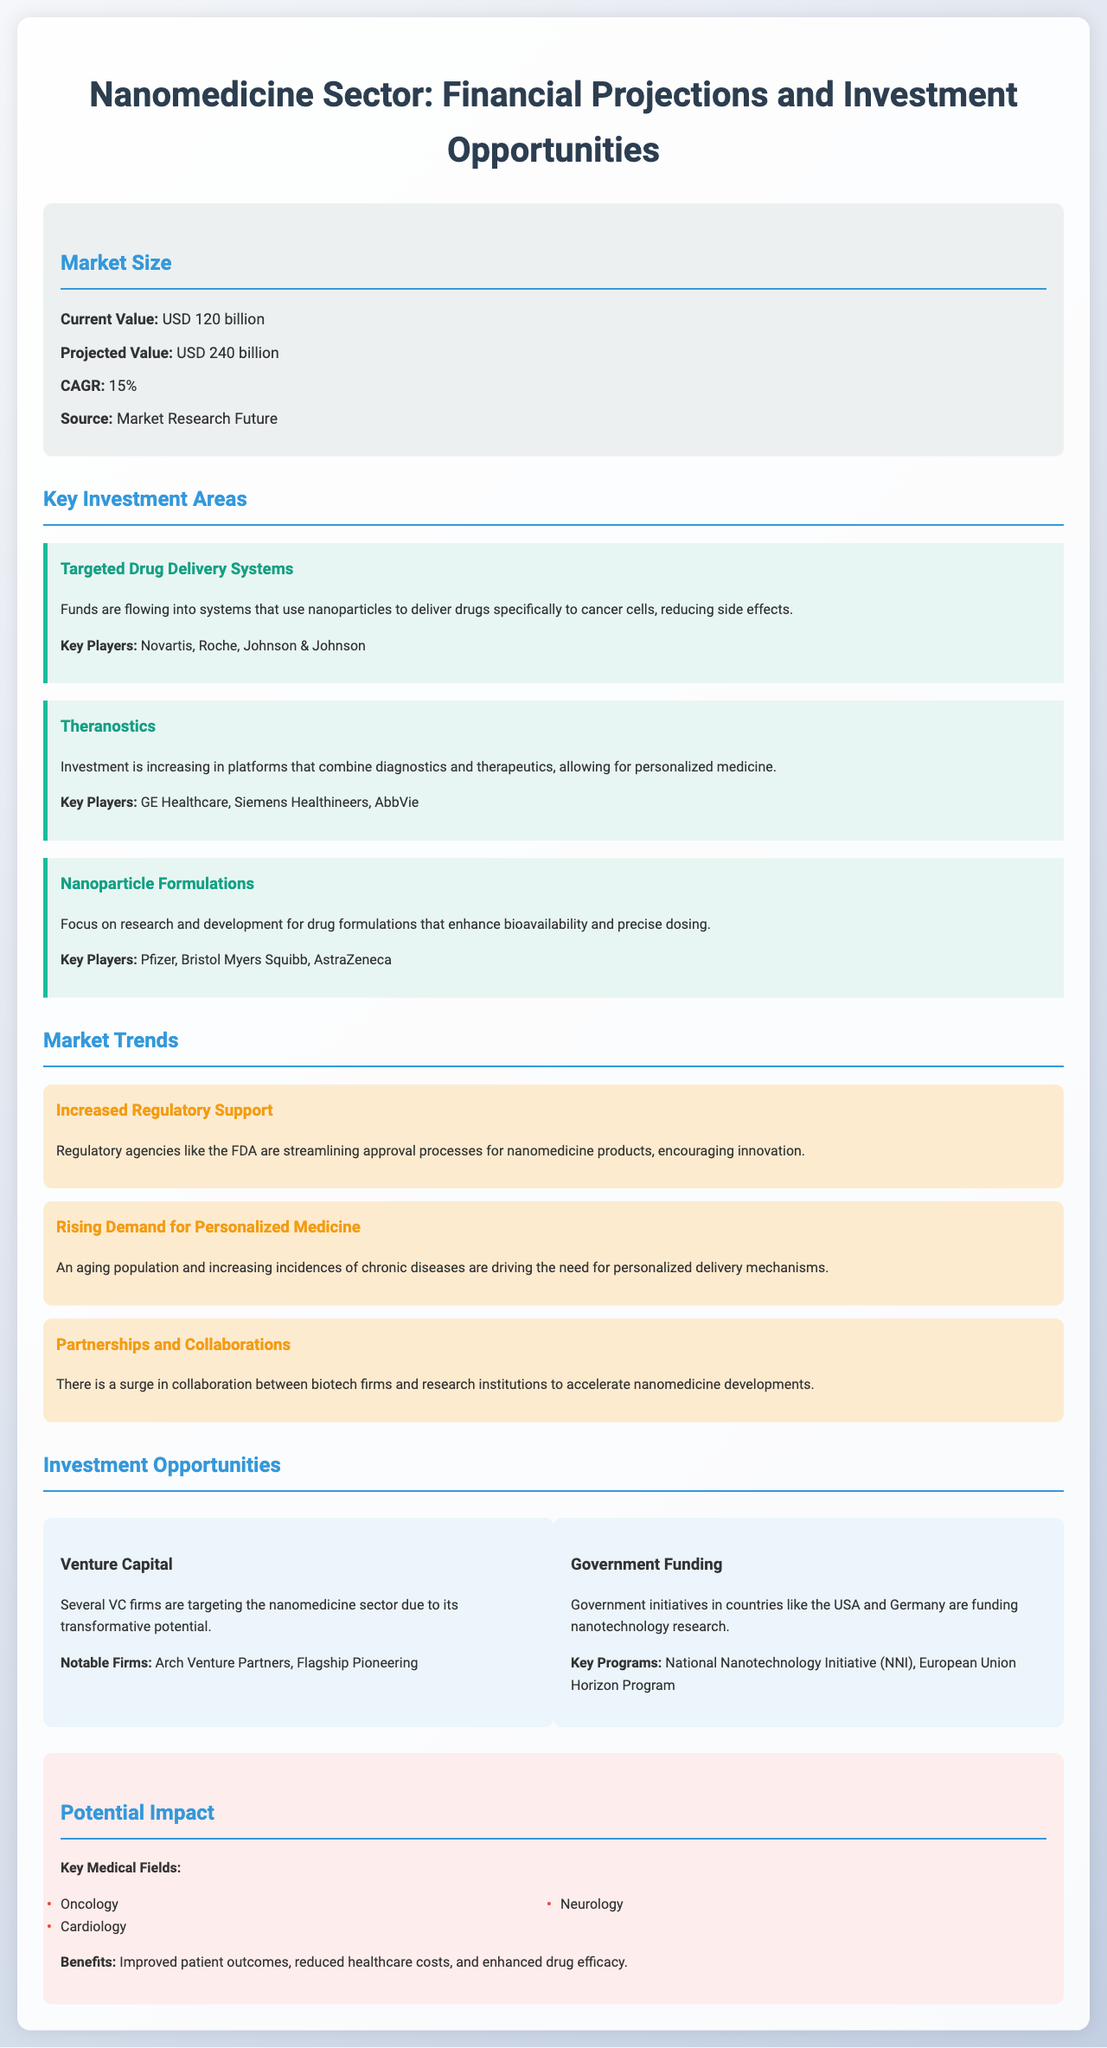What is the current value of the nanomedicine market? The current value is explicitly mentioned in the document as USD 120 billion.
Answer: USD 120 billion What is the projected value of the nanomedicine market? The projected value is also specified in the document as USD 240 billion.
Answer: USD 240 billion What is the CAGR for the nanomedicine market? The document provides the CAGR as a key statistic, which is 15%.
Answer: 15% Who are the key players in targeted drug delivery systems? Key players are listed in the document specifically as Novartis, Roche, and Johnson & Johnson.
Answer: Novartis, Roche, Johnson & Johnson What is one trend in the nanomedicine sector? The document outlines several trends, including "Increased Regulatory Support", clearly identifying emerging patterns in the market.
Answer: Increased Regulatory Support Which type of funding is highlighted as an opportunity in the document? The document mentions both venture capital and government funding as significant investment opportunities.
Answer: Venture Capital What are two key medical fields impacted by nanomedicine? The document lists several fields, including oncology and cardiology as significant areas of impact.
Answer: Oncology, Cardiology What is one notable venture capital firm mentioned? The document highlights Arch Venture Partners as a notable VC firm in the nanomedicine sector.
Answer: Arch Venture Partners What impact does nanomedicine aim to have on healthcare costs? The document states that one of the benefits of nanomedicine includes "reduced healthcare costs".
Answer: Reduced healthcare costs 